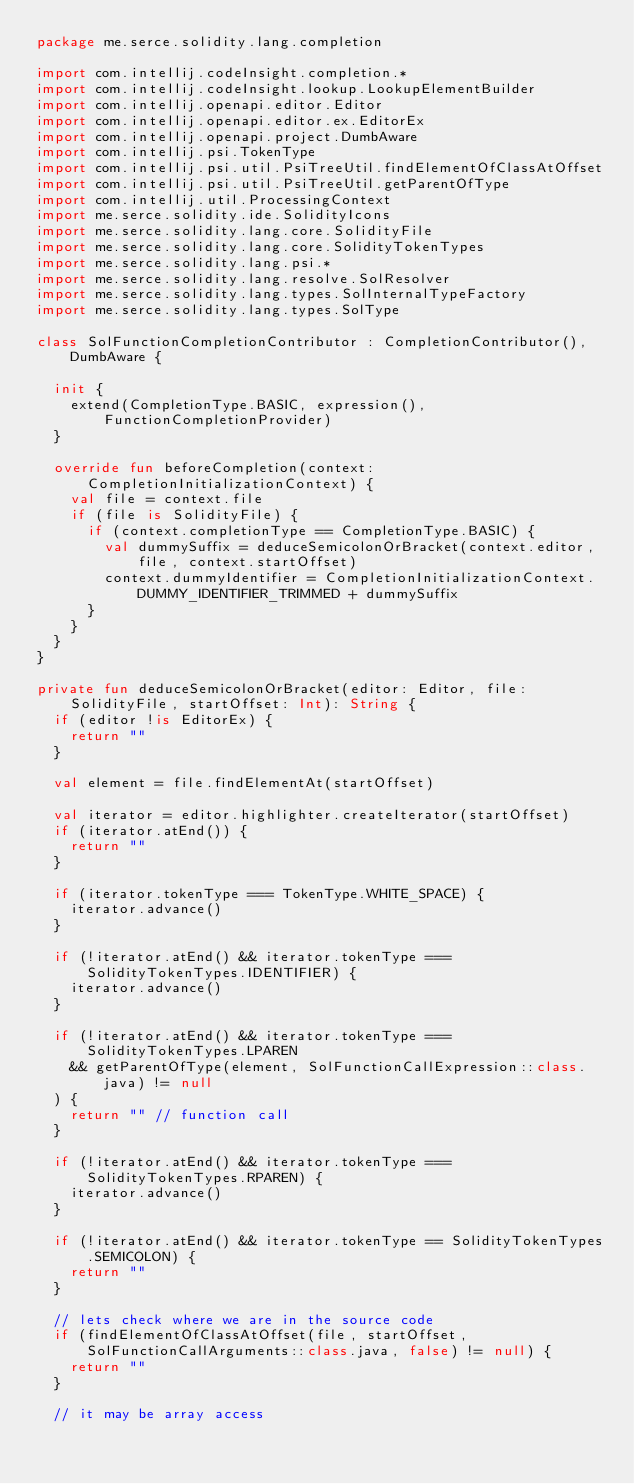Convert code to text. <code><loc_0><loc_0><loc_500><loc_500><_Kotlin_>package me.serce.solidity.lang.completion

import com.intellij.codeInsight.completion.*
import com.intellij.codeInsight.lookup.LookupElementBuilder
import com.intellij.openapi.editor.Editor
import com.intellij.openapi.editor.ex.EditorEx
import com.intellij.openapi.project.DumbAware
import com.intellij.psi.TokenType
import com.intellij.psi.util.PsiTreeUtil.findElementOfClassAtOffset
import com.intellij.psi.util.PsiTreeUtil.getParentOfType
import com.intellij.util.ProcessingContext
import me.serce.solidity.ide.SolidityIcons
import me.serce.solidity.lang.core.SolidityFile
import me.serce.solidity.lang.core.SolidityTokenTypes
import me.serce.solidity.lang.psi.*
import me.serce.solidity.lang.resolve.SolResolver
import me.serce.solidity.lang.types.SolInternalTypeFactory
import me.serce.solidity.lang.types.SolType

class SolFunctionCompletionContributor : CompletionContributor(), DumbAware {

  init {
    extend(CompletionType.BASIC, expression(), FunctionCompletionProvider)
  }

  override fun beforeCompletion(context: CompletionInitializationContext) {
    val file = context.file
    if (file is SolidityFile) {
      if (context.completionType == CompletionType.BASIC) {
        val dummySuffix = deduceSemicolonOrBracket(context.editor, file, context.startOffset)
        context.dummyIdentifier = CompletionInitializationContext.DUMMY_IDENTIFIER_TRIMMED + dummySuffix
      }
    }
  }
}

private fun deduceSemicolonOrBracket(editor: Editor, file: SolidityFile, startOffset: Int): String {
  if (editor !is EditorEx) {
    return ""
  }

  val element = file.findElementAt(startOffset)

  val iterator = editor.highlighter.createIterator(startOffset)
  if (iterator.atEnd()) {
    return ""
  }

  if (iterator.tokenType === TokenType.WHITE_SPACE) {
    iterator.advance()
  }

  if (!iterator.atEnd() && iterator.tokenType === SolidityTokenTypes.IDENTIFIER) {
    iterator.advance()
  }

  if (!iterator.atEnd() && iterator.tokenType === SolidityTokenTypes.LPAREN
    && getParentOfType(element, SolFunctionCallExpression::class.java) != null
  ) {
    return "" // function call
  }

  if (!iterator.atEnd() && iterator.tokenType === SolidityTokenTypes.RPAREN) {
    iterator.advance()
  }

  if (!iterator.atEnd() && iterator.tokenType == SolidityTokenTypes.SEMICOLON) {
    return ""
  }

  // lets check where we are in the source code
  if (findElementOfClassAtOffset(file, startOffset, SolFunctionCallArguments::class.java, false) != null) {
    return ""
  }

  // it may be array access</code> 